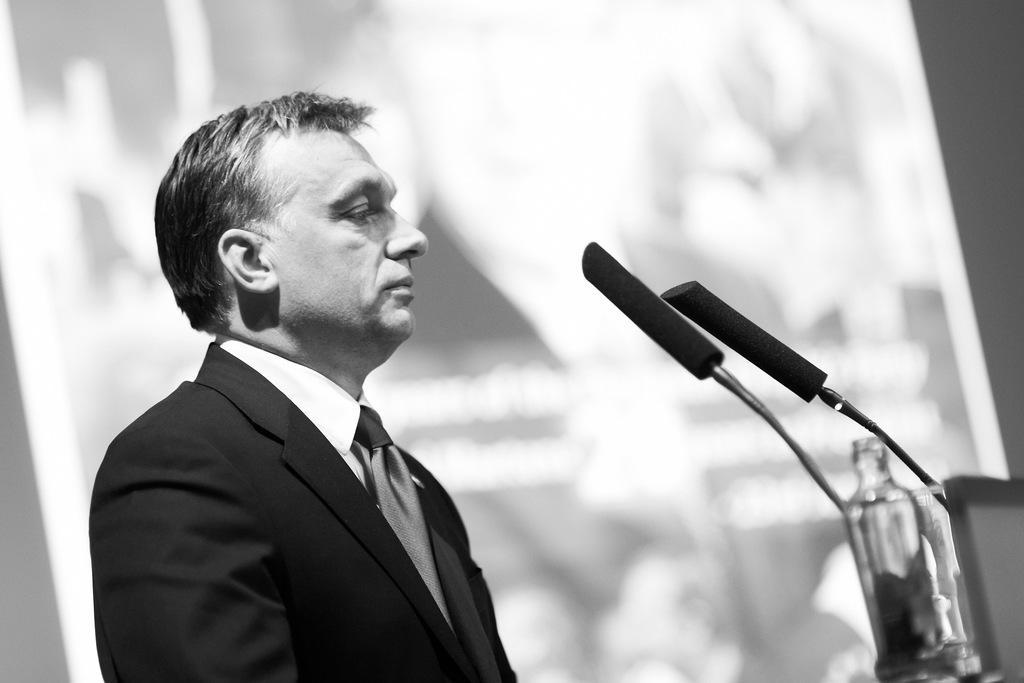Please provide a concise description of this image. In this image we can see few microphones and a bottle. There is a person in the image. There is a blur background in the image. 